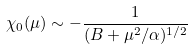<formula> <loc_0><loc_0><loc_500><loc_500>\chi _ { 0 } ( \mu ) \sim - \frac { 1 } { ( B + \mu ^ { 2 } / \alpha ) ^ { 1 / 2 } }</formula> 